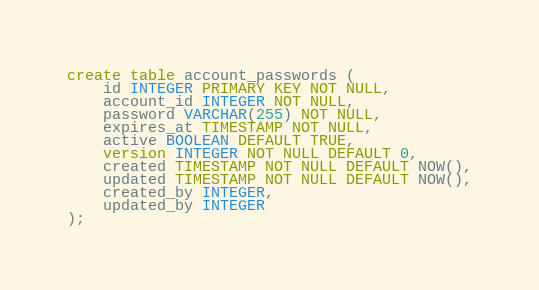<code> <loc_0><loc_0><loc_500><loc_500><_SQL_>create table account_passwords (
    id INTEGER PRIMARY KEY NOT NULL,
    account_id INTEGER NOT NULL,
    password VARCHAR(255) NOT NULL,
    expires_at TIMESTAMP NOT NULL,
    active BOOLEAN DEFAULT TRUE,
    version INTEGER NOT NULL DEFAULT 0,
    created TIMESTAMP NOT NULL DEFAULT NOW(),
    updated TIMESTAMP NOT NULL DEFAULT NOW(),
    created_by INTEGER,
    updated_by INTEGER
);
</code> 